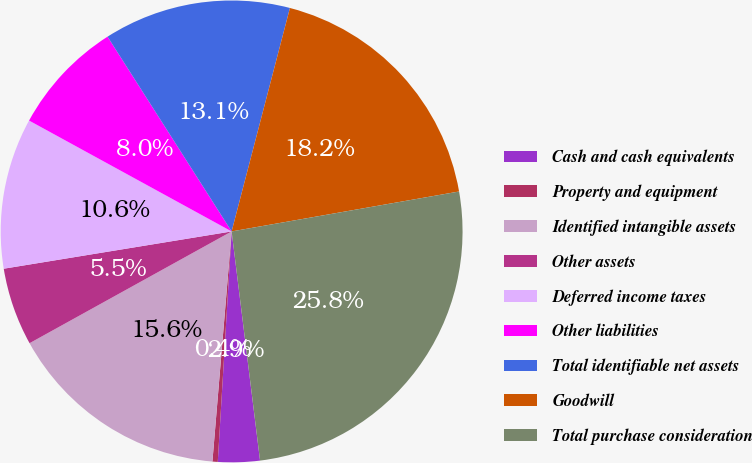Convert chart. <chart><loc_0><loc_0><loc_500><loc_500><pie_chart><fcel>Cash and cash equivalents<fcel>Property and equipment<fcel>Identified intangible assets<fcel>Other assets<fcel>Deferred income taxes<fcel>Other liabilities<fcel>Total identifiable net assets<fcel>Goodwill<fcel>Total purchase consideration<nl><fcel>2.92%<fcel>0.37%<fcel>15.63%<fcel>5.46%<fcel>10.55%<fcel>8.0%<fcel>13.09%<fcel>18.17%<fcel>25.8%<nl></chart> 